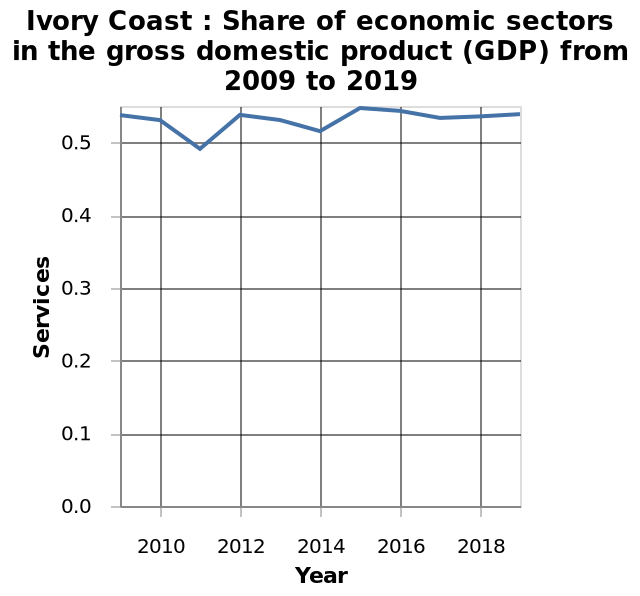<image>
please summary the statistics and relations of the chart I can observe that the line stays toward the top of the graph, indicating a high number of services for the Ivory Coast. I also notice that. the line goes up and down. 